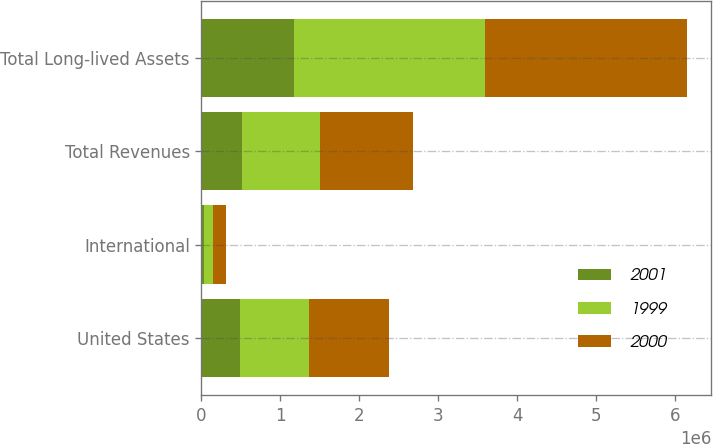<chart> <loc_0><loc_0><loc_500><loc_500><stacked_bar_chart><ecel><fcel>United States<fcel>International<fcel>Total Revenues<fcel>Total Long-lived Assets<nl><fcel>2001<fcel>487931<fcel>31618<fcel>519549<fcel>1.17355e+06<nl><fcel>1999<fcel>869684<fcel>116687<fcel>986371<fcel>2.42243e+06<nl><fcel>2000<fcel>1.01362e+06<fcel>157499<fcel>1.17112e+06<fcel>2.55059e+06<nl></chart> 